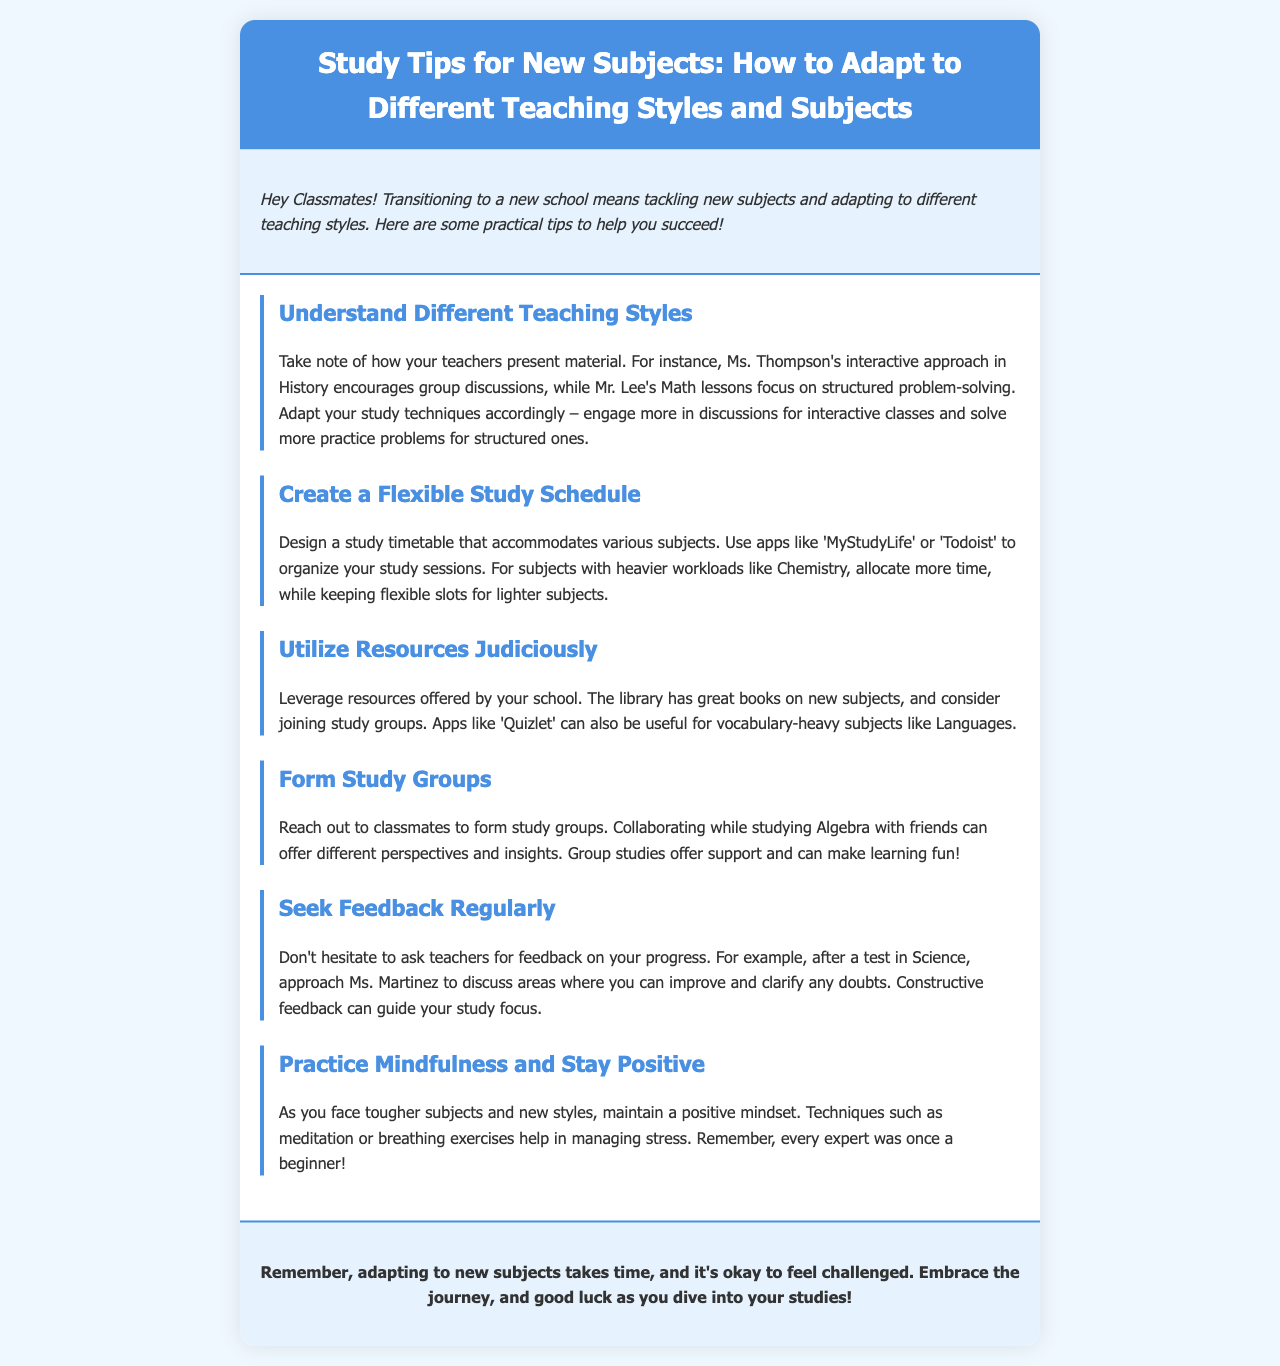What is the title of the newsletter? The title of the newsletter is mentioned in the header section, which outlines the main focus of the document.
Answer: Study Tips for New Subjects: How to Adapt to Different Teaching Styles and Subjects How many tips are provided in the document? The document enumerates each tip clearly, allowing us to count them easily for a total.
Answer: Six Which teaching style does Ms. Thompson use? The document specifies the teaching style of Ms. Thompson, indicating how she presents material in her classes.
Answer: Interactive What app is suggested for organizing study sessions? The document mentions specific apps that can help with organizing study sessions effectively.
Answer: MyStudyLife What subject may require a heavier workload according to the tips? The tips highlight how to allocate time and effort based on the demand of different subjects mentioned.
Answer: Chemistry Why should students form study groups? The document provides reasoning behind the benefits of studying collaboratively among peers.
Answer: Support and different perspectives What mindfulness techniques are recommended? The conclusion outlines methods to manage stress and maintain positivity while studying.
Answer: Meditation or breathing exercises Who should students ask for feedback on their progress? The document suggests reaching out to specific individuals who can provide constructive feedback regarding performance.
Answer: Teachers 